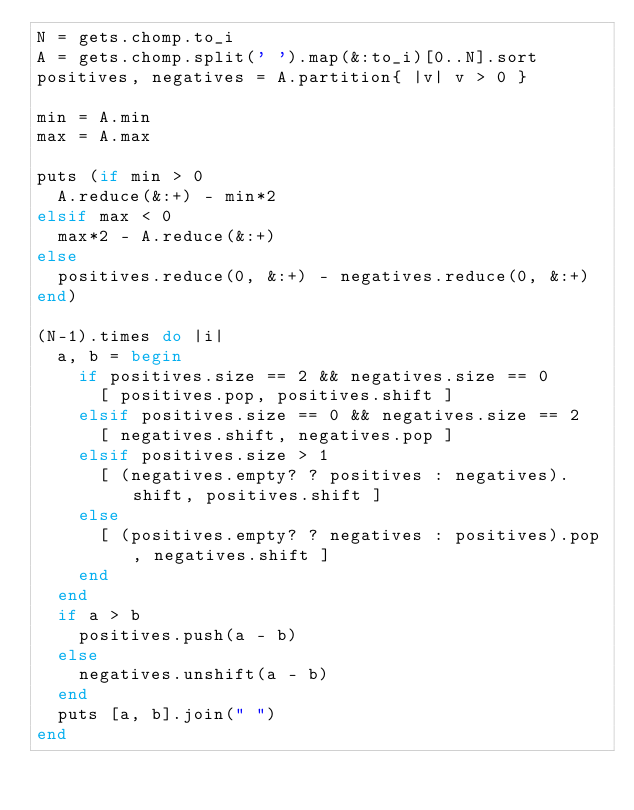<code> <loc_0><loc_0><loc_500><loc_500><_Ruby_>N = gets.chomp.to_i
A = gets.chomp.split(' ').map(&:to_i)[0..N].sort
positives, negatives = A.partition{ |v| v > 0 }

min = A.min
max = A.max

puts (if min > 0
  A.reduce(&:+) - min*2
elsif max < 0
  max*2 - A.reduce(&:+)
else
  positives.reduce(0, &:+) - negatives.reduce(0, &:+)
end)

(N-1).times do |i|
  a, b = begin
    if positives.size == 2 && negatives.size == 0
      [ positives.pop, positives.shift ]
    elsif positives.size == 0 && negatives.size == 2
      [ negatives.shift, negatives.pop ]
    elsif positives.size > 1
      [ (negatives.empty? ? positives : negatives).shift, positives.shift ]
    else
      [ (positives.empty? ? negatives : positives).pop, negatives.shift ]
    end
  end
  if a > b 
    positives.push(a - b)
  else
    negatives.unshift(a - b)
  end
  puts [a, b].join(" ")
end
</code> 